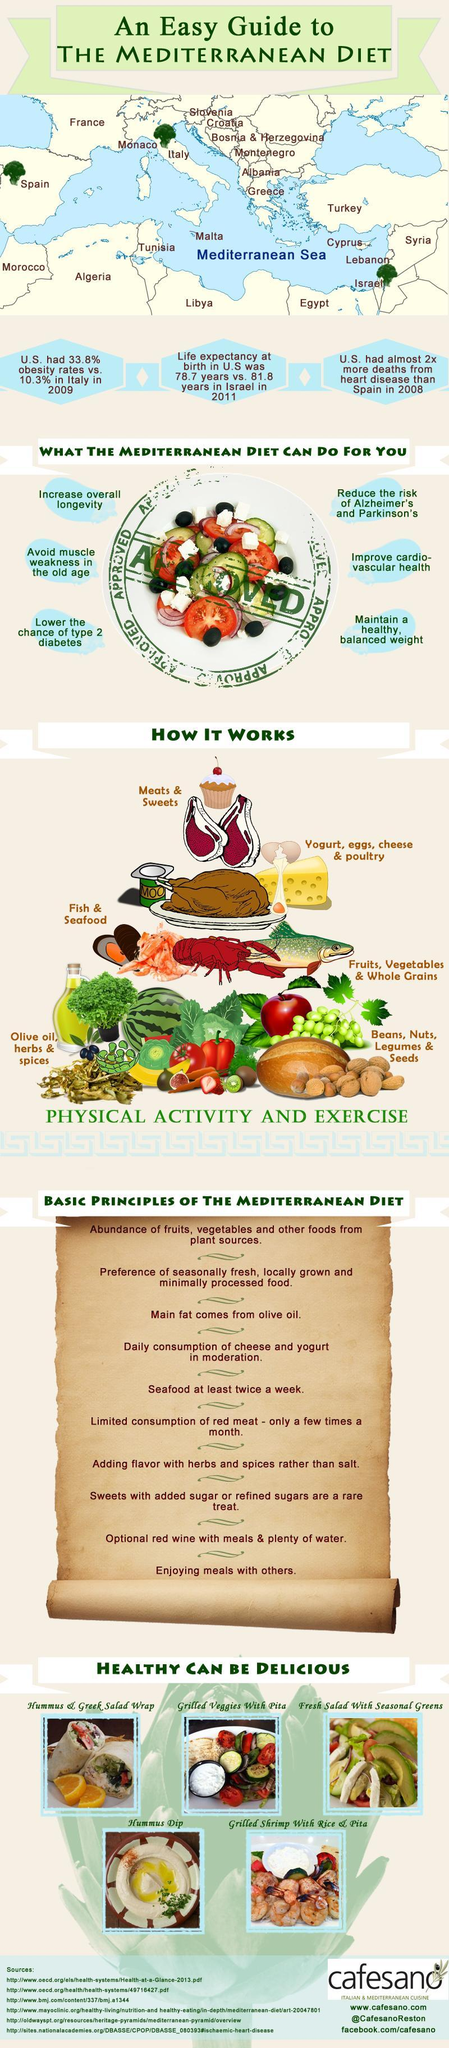How many uses are for the Mediterranean diet?
Answer the question with a short phrase. 6 How many principles are there for the Mediterranean diet? 10 